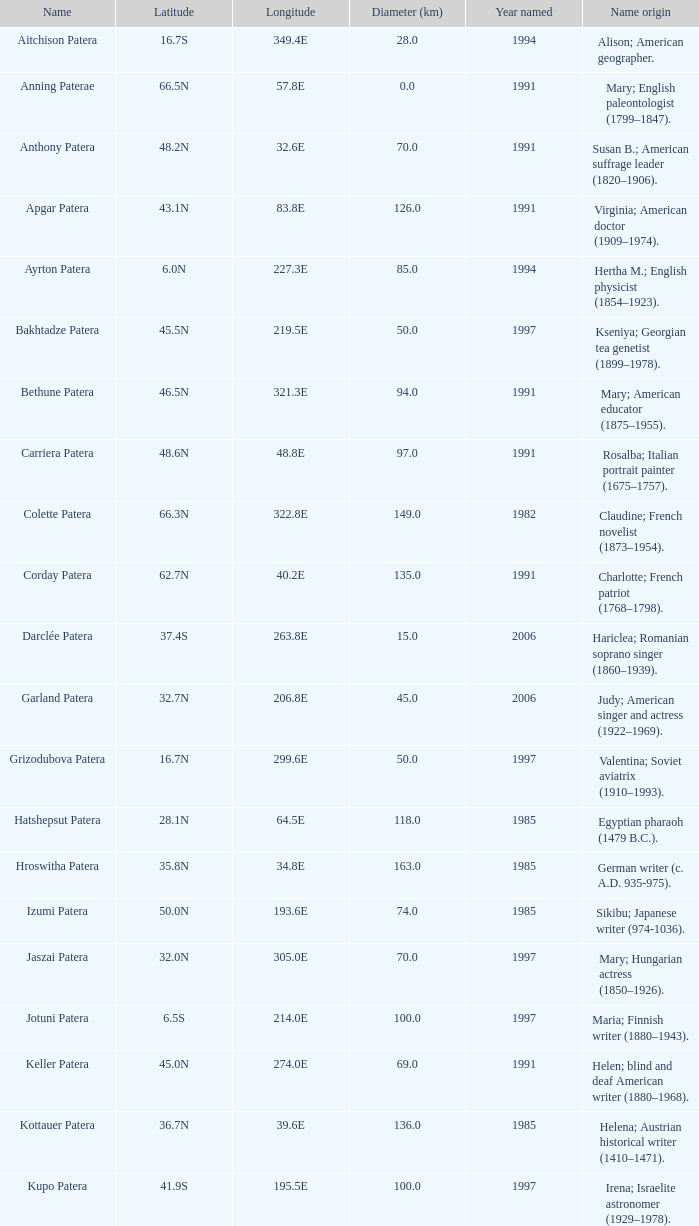What is the size in km across the feature referred to as colette patera? 149.0. 